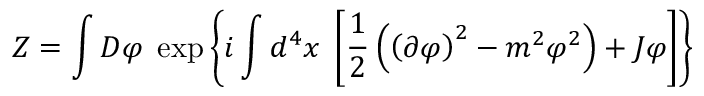<formula> <loc_0><loc_0><loc_500><loc_500>Z = \int D \varphi \, \exp \left \{ i \int d ^ { 4 } x \, \left [ { \frac { 1 } { 2 } } \left ( \left ( \partial \varphi \right ) ^ { 2 } - m ^ { 2 } \varphi ^ { 2 } \right ) + J \varphi \right ] \right \}</formula> 